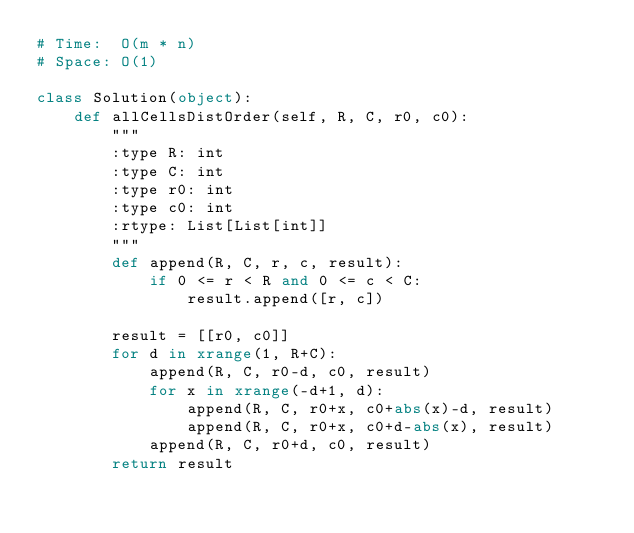Convert code to text. <code><loc_0><loc_0><loc_500><loc_500><_Python_># Time:  O(m * n)
# Space: O(1)

class Solution(object):
    def allCellsDistOrder(self, R, C, r0, c0):
        """
        :type R: int
        :type C: int
        :type r0: int
        :type c0: int
        :rtype: List[List[int]]
        """
        def append(R, C, r, c, result):
            if 0 <= r < R and 0 <= c < C:
                result.append([r, c])
            
        result = [[r0, c0]]
        for d in xrange(1, R+C):
            append(R, C, r0-d, c0, result)
            for x in xrange(-d+1, d):
                append(R, C, r0+x, c0+abs(x)-d, result)
                append(R, C, r0+x, c0+d-abs(x), result)
            append(R, C, r0+d, c0, result)
        return result
</code> 